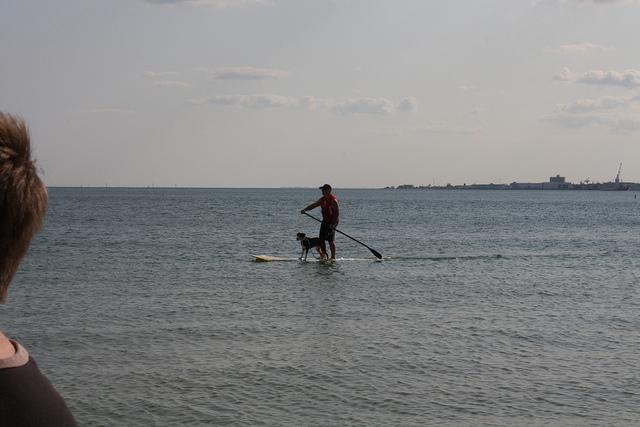What color is the board?
Quick response, please. White. What is this person riding?
Concise answer only. Surfboard. Is this a good day for surfing?
Give a very brief answer. No. Are there waves in the water?
Be succinct. No. What is the dog looking at?
Concise answer only. Water. What is this man holding?
Concise answer only. Paddle. Are they holding the surfboard?
Short answer required. No. Is it warm?
Short answer required. Yes. Is this a computer generated image?
Quick response, please. No. What is he wearing?
Quick response, please. Shorts. What animal is in the background?
Write a very short answer. Dog. What is this sport?
Keep it brief. Paddle boarding. Where is the dog at?
Be succinct. Surfboard. Is the dog wearing a life vest?
Keep it brief. No. Is this an appaloosa horse?
Give a very brief answer. No. What is the man holding?
Concise answer only. Paddle. Is the dog on the surfboard?
Write a very short answer. Yes. What breed of dog is it?
Be succinct. Lab. What is the man carrying?
Quick response, please. Paddle. Which swimmer has the palest skin?
Answer briefly. No swimmer. Is the sky cloudy?
Write a very short answer. No. Is this a surfboard?
Quick response, please. Yes. Is the man surfing?
Keep it brief. No. What is covering the ground?
Answer briefly. Water. Is this man at the beach?
Write a very short answer. Yes. What is he doing?
Concise answer only. Paddle boarding. How many kids could that surfboard seat?
Write a very short answer. 1. What is the person holding the surfboard standing on?
Be succinct. Surfboard. What creatures are swimming in the water?
Quick response, please. Fish. Is the man wearing glasses?
Answer briefly. No. What is the structure going in to the water?
Concise answer only. Paddle board. Is the dog swimming in the lake?
Be succinct. No. Are they going on a boat?
Keep it brief. No. What color is the dog?
Keep it brief. Black. What type of person would we consider the man in this image?
Keep it brief. Surfer. What action is the man performing?
Keep it brief. Rowing. What sport is being played?
Be succinct. Surfing. What does the man have in his right hand?
Keep it brief. Paddle. Is this sailboat in the water?
Be succinct. No. What are the surfers wearing?
Quick response, please. Shorts. What is on the surfboard with the man?
Concise answer only. Dog. What sport is this?
Give a very brief answer. Surfing. What is the man wearing around his neck?
Short answer required. Shirt. What is this person holding?
Be succinct. Paddle. What is the person doing?
Short answer required. Paddle boarding. What is the person holding?
Give a very brief answer. Paddle. Can this man go for a swim?
Be succinct. Yes. 